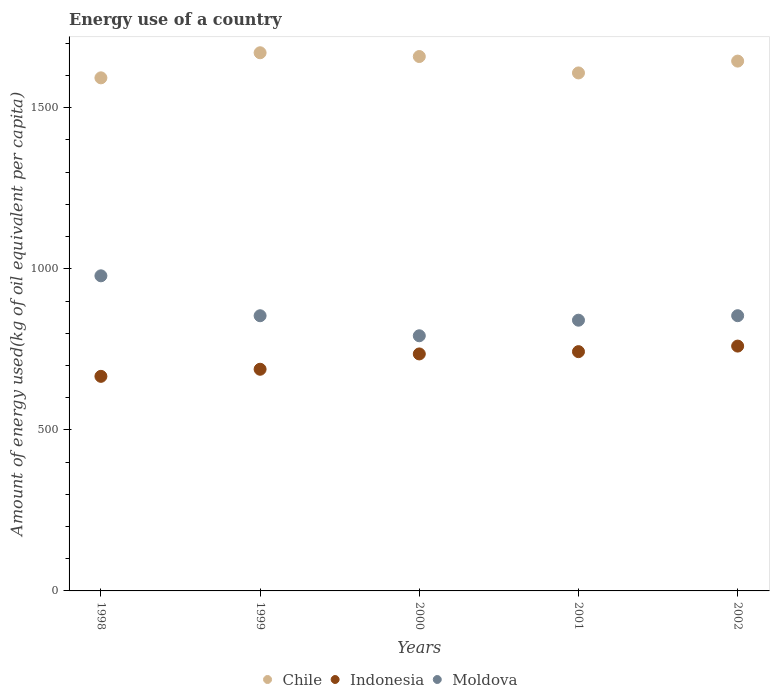Is the number of dotlines equal to the number of legend labels?
Offer a terse response. Yes. What is the amount of energy used in in Chile in 2000?
Your response must be concise. 1659.01. Across all years, what is the maximum amount of energy used in in Indonesia?
Your answer should be compact. 760.07. Across all years, what is the minimum amount of energy used in in Moldova?
Give a very brief answer. 792.1. What is the total amount of energy used in in Chile in the graph?
Keep it short and to the point. 8175.4. What is the difference between the amount of energy used in in Moldova in 1999 and that in 2002?
Your answer should be compact. -0.12. What is the difference between the amount of energy used in in Moldova in 1999 and the amount of energy used in in Indonesia in 2000?
Make the answer very short. 118.6. What is the average amount of energy used in in Indonesia per year?
Offer a very short reply. 718.57. In the year 2000, what is the difference between the amount of energy used in in Moldova and amount of energy used in in Indonesia?
Your response must be concise. 56.4. In how many years, is the amount of energy used in in Moldova greater than 1400 kg?
Keep it short and to the point. 0. What is the ratio of the amount of energy used in in Chile in 2001 to that in 2002?
Offer a very short reply. 0.98. What is the difference between the highest and the second highest amount of energy used in in Indonesia?
Your answer should be compact. 17.26. What is the difference between the highest and the lowest amount of energy used in in Indonesia?
Give a very brief answer. 93.93. In how many years, is the amount of energy used in in Moldova greater than the average amount of energy used in in Moldova taken over all years?
Your response must be concise. 1. Is the amount of energy used in in Moldova strictly greater than the amount of energy used in in Indonesia over the years?
Make the answer very short. Yes. Is the amount of energy used in in Moldova strictly less than the amount of energy used in in Indonesia over the years?
Ensure brevity in your answer.  No. Are the values on the major ticks of Y-axis written in scientific E-notation?
Your response must be concise. No. Where does the legend appear in the graph?
Offer a very short reply. Bottom center. How many legend labels are there?
Provide a short and direct response. 3. How are the legend labels stacked?
Keep it short and to the point. Horizontal. What is the title of the graph?
Provide a short and direct response. Energy use of a country. Does "Upper middle income" appear as one of the legend labels in the graph?
Ensure brevity in your answer.  No. What is the label or title of the Y-axis?
Your answer should be compact. Amount of energy used(kg of oil equivalent per capita). What is the Amount of energy used(kg of oil equivalent per capita) in Chile in 1998?
Keep it short and to the point. 1592.83. What is the Amount of energy used(kg of oil equivalent per capita) in Indonesia in 1998?
Provide a short and direct response. 666.13. What is the Amount of energy used(kg of oil equivalent per capita) of Moldova in 1998?
Your answer should be compact. 978.23. What is the Amount of energy used(kg of oil equivalent per capita) of Chile in 1999?
Your answer should be compact. 1670.7. What is the Amount of energy used(kg of oil equivalent per capita) in Indonesia in 1999?
Make the answer very short. 688.15. What is the Amount of energy used(kg of oil equivalent per capita) in Moldova in 1999?
Provide a short and direct response. 854.3. What is the Amount of energy used(kg of oil equivalent per capita) in Chile in 2000?
Offer a terse response. 1659.01. What is the Amount of energy used(kg of oil equivalent per capita) in Indonesia in 2000?
Your response must be concise. 735.7. What is the Amount of energy used(kg of oil equivalent per capita) of Moldova in 2000?
Your answer should be compact. 792.1. What is the Amount of energy used(kg of oil equivalent per capita) in Chile in 2001?
Make the answer very short. 1608.07. What is the Amount of energy used(kg of oil equivalent per capita) of Indonesia in 2001?
Offer a very short reply. 742.81. What is the Amount of energy used(kg of oil equivalent per capita) of Moldova in 2001?
Ensure brevity in your answer.  840.45. What is the Amount of energy used(kg of oil equivalent per capita) in Chile in 2002?
Make the answer very short. 1644.79. What is the Amount of energy used(kg of oil equivalent per capita) of Indonesia in 2002?
Provide a succinct answer. 760.07. What is the Amount of energy used(kg of oil equivalent per capita) in Moldova in 2002?
Keep it short and to the point. 854.42. Across all years, what is the maximum Amount of energy used(kg of oil equivalent per capita) of Chile?
Provide a short and direct response. 1670.7. Across all years, what is the maximum Amount of energy used(kg of oil equivalent per capita) in Indonesia?
Make the answer very short. 760.07. Across all years, what is the maximum Amount of energy used(kg of oil equivalent per capita) in Moldova?
Your answer should be compact. 978.23. Across all years, what is the minimum Amount of energy used(kg of oil equivalent per capita) of Chile?
Ensure brevity in your answer.  1592.83. Across all years, what is the minimum Amount of energy used(kg of oil equivalent per capita) of Indonesia?
Offer a terse response. 666.13. Across all years, what is the minimum Amount of energy used(kg of oil equivalent per capita) in Moldova?
Provide a short and direct response. 792.1. What is the total Amount of energy used(kg of oil equivalent per capita) in Chile in the graph?
Offer a very short reply. 8175.4. What is the total Amount of energy used(kg of oil equivalent per capita) of Indonesia in the graph?
Offer a very short reply. 3592.85. What is the total Amount of energy used(kg of oil equivalent per capita) of Moldova in the graph?
Provide a succinct answer. 4319.5. What is the difference between the Amount of energy used(kg of oil equivalent per capita) of Chile in 1998 and that in 1999?
Give a very brief answer. -77.87. What is the difference between the Amount of energy used(kg of oil equivalent per capita) of Indonesia in 1998 and that in 1999?
Offer a terse response. -22.01. What is the difference between the Amount of energy used(kg of oil equivalent per capita) in Moldova in 1998 and that in 1999?
Offer a terse response. 123.93. What is the difference between the Amount of energy used(kg of oil equivalent per capita) in Chile in 1998 and that in 2000?
Provide a succinct answer. -66.17. What is the difference between the Amount of energy used(kg of oil equivalent per capita) in Indonesia in 1998 and that in 2000?
Your answer should be compact. -69.57. What is the difference between the Amount of energy used(kg of oil equivalent per capita) in Moldova in 1998 and that in 2000?
Your answer should be very brief. 186.12. What is the difference between the Amount of energy used(kg of oil equivalent per capita) in Chile in 1998 and that in 2001?
Your answer should be very brief. -15.24. What is the difference between the Amount of energy used(kg of oil equivalent per capita) of Indonesia in 1998 and that in 2001?
Make the answer very short. -76.67. What is the difference between the Amount of energy used(kg of oil equivalent per capita) in Moldova in 1998 and that in 2001?
Keep it short and to the point. 137.78. What is the difference between the Amount of energy used(kg of oil equivalent per capita) of Chile in 1998 and that in 2002?
Offer a very short reply. -51.96. What is the difference between the Amount of energy used(kg of oil equivalent per capita) in Indonesia in 1998 and that in 2002?
Make the answer very short. -93.93. What is the difference between the Amount of energy used(kg of oil equivalent per capita) in Moldova in 1998 and that in 2002?
Offer a terse response. 123.81. What is the difference between the Amount of energy used(kg of oil equivalent per capita) of Chile in 1999 and that in 2000?
Give a very brief answer. 11.69. What is the difference between the Amount of energy used(kg of oil equivalent per capita) in Indonesia in 1999 and that in 2000?
Offer a terse response. -47.55. What is the difference between the Amount of energy used(kg of oil equivalent per capita) in Moldova in 1999 and that in 2000?
Your answer should be compact. 62.19. What is the difference between the Amount of energy used(kg of oil equivalent per capita) of Chile in 1999 and that in 2001?
Your response must be concise. 62.63. What is the difference between the Amount of energy used(kg of oil equivalent per capita) in Indonesia in 1999 and that in 2001?
Your response must be concise. -54.66. What is the difference between the Amount of energy used(kg of oil equivalent per capita) in Moldova in 1999 and that in 2001?
Ensure brevity in your answer.  13.85. What is the difference between the Amount of energy used(kg of oil equivalent per capita) in Chile in 1999 and that in 2002?
Offer a terse response. 25.91. What is the difference between the Amount of energy used(kg of oil equivalent per capita) in Indonesia in 1999 and that in 2002?
Your response must be concise. -71.92. What is the difference between the Amount of energy used(kg of oil equivalent per capita) of Moldova in 1999 and that in 2002?
Offer a very short reply. -0.12. What is the difference between the Amount of energy used(kg of oil equivalent per capita) in Chile in 2000 and that in 2001?
Your answer should be compact. 50.94. What is the difference between the Amount of energy used(kg of oil equivalent per capita) in Indonesia in 2000 and that in 2001?
Make the answer very short. -7.11. What is the difference between the Amount of energy used(kg of oil equivalent per capita) in Moldova in 2000 and that in 2001?
Ensure brevity in your answer.  -48.35. What is the difference between the Amount of energy used(kg of oil equivalent per capita) of Chile in 2000 and that in 2002?
Make the answer very short. 14.21. What is the difference between the Amount of energy used(kg of oil equivalent per capita) in Indonesia in 2000 and that in 2002?
Your response must be concise. -24.37. What is the difference between the Amount of energy used(kg of oil equivalent per capita) of Moldova in 2000 and that in 2002?
Give a very brief answer. -62.32. What is the difference between the Amount of energy used(kg of oil equivalent per capita) of Chile in 2001 and that in 2002?
Make the answer very short. -36.72. What is the difference between the Amount of energy used(kg of oil equivalent per capita) in Indonesia in 2001 and that in 2002?
Provide a succinct answer. -17.26. What is the difference between the Amount of energy used(kg of oil equivalent per capita) in Moldova in 2001 and that in 2002?
Offer a terse response. -13.97. What is the difference between the Amount of energy used(kg of oil equivalent per capita) of Chile in 1998 and the Amount of energy used(kg of oil equivalent per capita) of Indonesia in 1999?
Ensure brevity in your answer.  904.69. What is the difference between the Amount of energy used(kg of oil equivalent per capita) of Chile in 1998 and the Amount of energy used(kg of oil equivalent per capita) of Moldova in 1999?
Your response must be concise. 738.54. What is the difference between the Amount of energy used(kg of oil equivalent per capita) in Indonesia in 1998 and the Amount of energy used(kg of oil equivalent per capita) in Moldova in 1999?
Your answer should be compact. -188.16. What is the difference between the Amount of energy used(kg of oil equivalent per capita) in Chile in 1998 and the Amount of energy used(kg of oil equivalent per capita) in Indonesia in 2000?
Make the answer very short. 857.13. What is the difference between the Amount of energy used(kg of oil equivalent per capita) of Chile in 1998 and the Amount of energy used(kg of oil equivalent per capita) of Moldova in 2000?
Your response must be concise. 800.73. What is the difference between the Amount of energy used(kg of oil equivalent per capita) of Indonesia in 1998 and the Amount of energy used(kg of oil equivalent per capita) of Moldova in 2000?
Your answer should be very brief. -125.97. What is the difference between the Amount of energy used(kg of oil equivalent per capita) of Chile in 1998 and the Amount of energy used(kg of oil equivalent per capita) of Indonesia in 2001?
Ensure brevity in your answer.  850.03. What is the difference between the Amount of energy used(kg of oil equivalent per capita) of Chile in 1998 and the Amount of energy used(kg of oil equivalent per capita) of Moldova in 2001?
Ensure brevity in your answer.  752.38. What is the difference between the Amount of energy used(kg of oil equivalent per capita) in Indonesia in 1998 and the Amount of energy used(kg of oil equivalent per capita) in Moldova in 2001?
Your answer should be compact. -174.32. What is the difference between the Amount of energy used(kg of oil equivalent per capita) of Chile in 1998 and the Amount of energy used(kg of oil equivalent per capita) of Indonesia in 2002?
Keep it short and to the point. 832.77. What is the difference between the Amount of energy used(kg of oil equivalent per capita) of Chile in 1998 and the Amount of energy used(kg of oil equivalent per capita) of Moldova in 2002?
Provide a succinct answer. 738.41. What is the difference between the Amount of energy used(kg of oil equivalent per capita) of Indonesia in 1998 and the Amount of energy used(kg of oil equivalent per capita) of Moldova in 2002?
Provide a succinct answer. -188.29. What is the difference between the Amount of energy used(kg of oil equivalent per capita) in Chile in 1999 and the Amount of energy used(kg of oil equivalent per capita) in Indonesia in 2000?
Give a very brief answer. 935. What is the difference between the Amount of energy used(kg of oil equivalent per capita) of Chile in 1999 and the Amount of energy used(kg of oil equivalent per capita) of Moldova in 2000?
Offer a very short reply. 878.6. What is the difference between the Amount of energy used(kg of oil equivalent per capita) in Indonesia in 1999 and the Amount of energy used(kg of oil equivalent per capita) in Moldova in 2000?
Offer a terse response. -103.96. What is the difference between the Amount of energy used(kg of oil equivalent per capita) of Chile in 1999 and the Amount of energy used(kg of oil equivalent per capita) of Indonesia in 2001?
Offer a terse response. 927.89. What is the difference between the Amount of energy used(kg of oil equivalent per capita) of Chile in 1999 and the Amount of energy used(kg of oil equivalent per capita) of Moldova in 2001?
Provide a succinct answer. 830.25. What is the difference between the Amount of energy used(kg of oil equivalent per capita) in Indonesia in 1999 and the Amount of energy used(kg of oil equivalent per capita) in Moldova in 2001?
Offer a terse response. -152.3. What is the difference between the Amount of energy used(kg of oil equivalent per capita) in Chile in 1999 and the Amount of energy used(kg of oil equivalent per capita) in Indonesia in 2002?
Provide a short and direct response. 910.63. What is the difference between the Amount of energy used(kg of oil equivalent per capita) of Chile in 1999 and the Amount of energy used(kg of oil equivalent per capita) of Moldova in 2002?
Offer a very short reply. 816.28. What is the difference between the Amount of energy used(kg of oil equivalent per capita) of Indonesia in 1999 and the Amount of energy used(kg of oil equivalent per capita) of Moldova in 2002?
Offer a very short reply. -166.27. What is the difference between the Amount of energy used(kg of oil equivalent per capita) of Chile in 2000 and the Amount of energy used(kg of oil equivalent per capita) of Indonesia in 2001?
Keep it short and to the point. 916.2. What is the difference between the Amount of energy used(kg of oil equivalent per capita) in Chile in 2000 and the Amount of energy used(kg of oil equivalent per capita) in Moldova in 2001?
Give a very brief answer. 818.56. What is the difference between the Amount of energy used(kg of oil equivalent per capita) of Indonesia in 2000 and the Amount of energy used(kg of oil equivalent per capita) of Moldova in 2001?
Keep it short and to the point. -104.75. What is the difference between the Amount of energy used(kg of oil equivalent per capita) of Chile in 2000 and the Amount of energy used(kg of oil equivalent per capita) of Indonesia in 2002?
Keep it short and to the point. 898.94. What is the difference between the Amount of energy used(kg of oil equivalent per capita) in Chile in 2000 and the Amount of energy used(kg of oil equivalent per capita) in Moldova in 2002?
Provide a succinct answer. 804.59. What is the difference between the Amount of energy used(kg of oil equivalent per capita) in Indonesia in 2000 and the Amount of energy used(kg of oil equivalent per capita) in Moldova in 2002?
Make the answer very short. -118.72. What is the difference between the Amount of energy used(kg of oil equivalent per capita) in Chile in 2001 and the Amount of energy used(kg of oil equivalent per capita) in Indonesia in 2002?
Keep it short and to the point. 848. What is the difference between the Amount of energy used(kg of oil equivalent per capita) in Chile in 2001 and the Amount of energy used(kg of oil equivalent per capita) in Moldova in 2002?
Provide a short and direct response. 753.65. What is the difference between the Amount of energy used(kg of oil equivalent per capita) in Indonesia in 2001 and the Amount of energy used(kg of oil equivalent per capita) in Moldova in 2002?
Give a very brief answer. -111.61. What is the average Amount of energy used(kg of oil equivalent per capita) of Chile per year?
Offer a very short reply. 1635.08. What is the average Amount of energy used(kg of oil equivalent per capita) in Indonesia per year?
Your answer should be compact. 718.57. What is the average Amount of energy used(kg of oil equivalent per capita) of Moldova per year?
Give a very brief answer. 863.9. In the year 1998, what is the difference between the Amount of energy used(kg of oil equivalent per capita) of Chile and Amount of energy used(kg of oil equivalent per capita) of Indonesia?
Ensure brevity in your answer.  926.7. In the year 1998, what is the difference between the Amount of energy used(kg of oil equivalent per capita) in Chile and Amount of energy used(kg of oil equivalent per capita) in Moldova?
Ensure brevity in your answer.  614.61. In the year 1998, what is the difference between the Amount of energy used(kg of oil equivalent per capita) of Indonesia and Amount of energy used(kg of oil equivalent per capita) of Moldova?
Provide a short and direct response. -312.09. In the year 1999, what is the difference between the Amount of energy used(kg of oil equivalent per capita) of Chile and Amount of energy used(kg of oil equivalent per capita) of Indonesia?
Ensure brevity in your answer.  982.55. In the year 1999, what is the difference between the Amount of energy used(kg of oil equivalent per capita) of Chile and Amount of energy used(kg of oil equivalent per capita) of Moldova?
Offer a terse response. 816.4. In the year 1999, what is the difference between the Amount of energy used(kg of oil equivalent per capita) in Indonesia and Amount of energy used(kg of oil equivalent per capita) in Moldova?
Your response must be concise. -166.15. In the year 2000, what is the difference between the Amount of energy used(kg of oil equivalent per capita) of Chile and Amount of energy used(kg of oil equivalent per capita) of Indonesia?
Offer a very short reply. 923.31. In the year 2000, what is the difference between the Amount of energy used(kg of oil equivalent per capita) of Chile and Amount of energy used(kg of oil equivalent per capita) of Moldova?
Provide a succinct answer. 866.9. In the year 2000, what is the difference between the Amount of energy used(kg of oil equivalent per capita) of Indonesia and Amount of energy used(kg of oil equivalent per capita) of Moldova?
Make the answer very short. -56.4. In the year 2001, what is the difference between the Amount of energy used(kg of oil equivalent per capita) in Chile and Amount of energy used(kg of oil equivalent per capita) in Indonesia?
Your response must be concise. 865.26. In the year 2001, what is the difference between the Amount of energy used(kg of oil equivalent per capita) in Chile and Amount of energy used(kg of oil equivalent per capita) in Moldova?
Ensure brevity in your answer.  767.62. In the year 2001, what is the difference between the Amount of energy used(kg of oil equivalent per capita) in Indonesia and Amount of energy used(kg of oil equivalent per capita) in Moldova?
Ensure brevity in your answer.  -97.65. In the year 2002, what is the difference between the Amount of energy used(kg of oil equivalent per capita) in Chile and Amount of energy used(kg of oil equivalent per capita) in Indonesia?
Provide a succinct answer. 884.73. In the year 2002, what is the difference between the Amount of energy used(kg of oil equivalent per capita) of Chile and Amount of energy used(kg of oil equivalent per capita) of Moldova?
Ensure brevity in your answer.  790.37. In the year 2002, what is the difference between the Amount of energy used(kg of oil equivalent per capita) of Indonesia and Amount of energy used(kg of oil equivalent per capita) of Moldova?
Provide a succinct answer. -94.35. What is the ratio of the Amount of energy used(kg of oil equivalent per capita) of Chile in 1998 to that in 1999?
Provide a succinct answer. 0.95. What is the ratio of the Amount of energy used(kg of oil equivalent per capita) in Moldova in 1998 to that in 1999?
Your answer should be very brief. 1.15. What is the ratio of the Amount of energy used(kg of oil equivalent per capita) of Chile in 1998 to that in 2000?
Give a very brief answer. 0.96. What is the ratio of the Amount of energy used(kg of oil equivalent per capita) in Indonesia in 1998 to that in 2000?
Provide a short and direct response. 0.91. What is the ratio of the Amount of energy used(kg of oil equivalent per capita) in Moldova in 1998 to that in 2000?
Provide a succinct answer. 1.24. What is the ratio of the Amount of energy used(kg of oil equivalent per capita) in Indonesia in 1998 to that in 2001?
Offer a terse response. 0.9. What is the ratio of the Amount of energy used(kg of oil equivalent per capita) in Moldova in 1998 to that in 2001?
Offer a very short reply. 1.16. What is the ratio of the Amount of energy used(kg of oil equivalent per capita) of Chile in 1998 to that in 2002?
Make the answer very short. 0.97. What is the ratio of the Amount of energy used(kg of oil equivalent per capita) in Indonesia in 1998 to that in 2002?
Give a very brief answer. 0.88. What is the ratio of the Amount of energy used(kg of oil equivalent per capita) in Moldova in 1998 to that in 2002?
Ensure brevity in your answer.  1.14. What is the ratio of the Amount of energy used(kg of oil equivalent per capita) in Indonesia in 1999 to that in 2000?
Provide a succinct answer. 0.94. What is the ratio of the Amount of energy used(kg of oil equivalent per capita) of Moldova in 1999 to that in 2000?
Provide a short and direct response. 1.08. What is the ratio of the Amount of energy used(kg of oil equivalent per capita) in Chile in 1999 to that in 2001?
Ensure brevity in your answer.  1.04. What is the ratio of the Amount of energy used(kg of oil equivalent per capita) in Indonesia in 1999 to that in 2001?
Make the answer very short. 0.93. What is the ratio of the Amount of energy used(kg of oil equivalent per capita) in Moldova in 1999 to that in 2001?
Provide a succinct answer. 1.02. What is the ratio of the Amount of energy used(kg of oil equivalent per capita) of Chile in 1999 to that in 2002?
Offer a terse response. 1.02. What is the ratio of the Amount of energy used(kg of oil equivalent per capita) of Indonesia in 1999 to that in 2002?
Make the answer very short. 0.91. What is the ratio of the Amount of energy used(kg of oil equivalent per capita) in Chile in 2000 to that in 2001?
Your answer should be very brief. 1.03. What is the ratio of the Amount of energy used(kg of oil equivalent per capita) of Indonesia in 2000 to that in 2001?
Give a very brief answer. 0.99. What is the ratio of the Amount of energy used(kg of oil equivalent per capita) of Moldova in 2000 to that in 2001?
Ensure brevity in your answer.  0.94. What is the ratio of the Amount of energy used(kg of oil equivalent per capita) in Chile in 2000 to that in 2002?
Your answer should be compact. 1.01. What is the ratio of the Amount of energy used(kg of oil equivalent per capita) in Indonesia in 2000 to that in 2002?
Ensure brevity in your answer.  0.97. What is the ratio of the Amount of energy used(kg of oil equivalent per capita) in Moldova in 2000 to that in 2002?
Ensure brevity in your answer.  0.93. What is the ratio of the Amount of energy used(kg of oil equivalent per capita) in Chile in 2001 to that in 2002?
Offer a very short reply. 0.98. What is the ratio of the Amount of energy used(kg of oil equivalent per capita) in Indonesia in 2001 to that in 2002?
Provide a succinct answer. 0.98. What is the ratio of the Amount of energy used(kg of oil equivalent per capita) of Moldova in 2001 to that in 2002?
Provide a short and direct response. 0.98. What is the difference between the highest and the second highest Amount of energy used(kg of oil equivalent per capita) in Chile?
Provide a short and direct response. 11.69. What is the difference between the highest and the second highest Amount of energy used(kg of oil equivalent per capita) of Indonesia?
Give a very brief answer. 17.26. What is the difference between the highest and the second highest Amount of energy used(kg of oil equivalent per capita) in Moldova?
Offer a very short reply. 123.81. What is the difference between the highest and the lowest Amount of energy used(kg of oil equivalent per capita) in Chile?
Offer a terse response. 77.87. What is the difference between the highest and the lowest Amount of energy used(kg of oil equivalent per capita) in Indonesia?
Provide a succinct answer. 93.93. What is the difference between the highest and the lowest Amount of energy used(kg of oil equivalent per capita) in Moldova?
Provide a short and direct response. 186.12. 